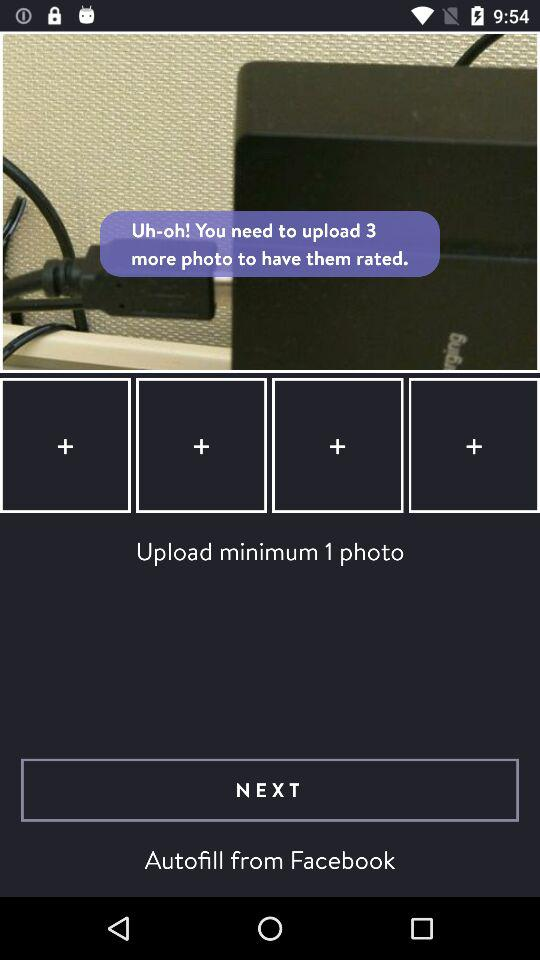How many photos need to be uploaded to have them rated? There are 3 photos that need to be uploaded. 